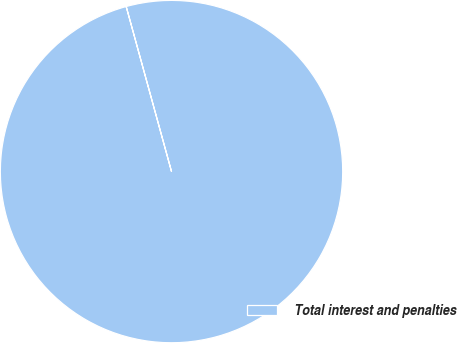<chart> <loc_0><loc_0><loc_500><loc_500><pie_chart><fcel>Total interest and penalties<nl><fcel>100.0%<nl></chart> 